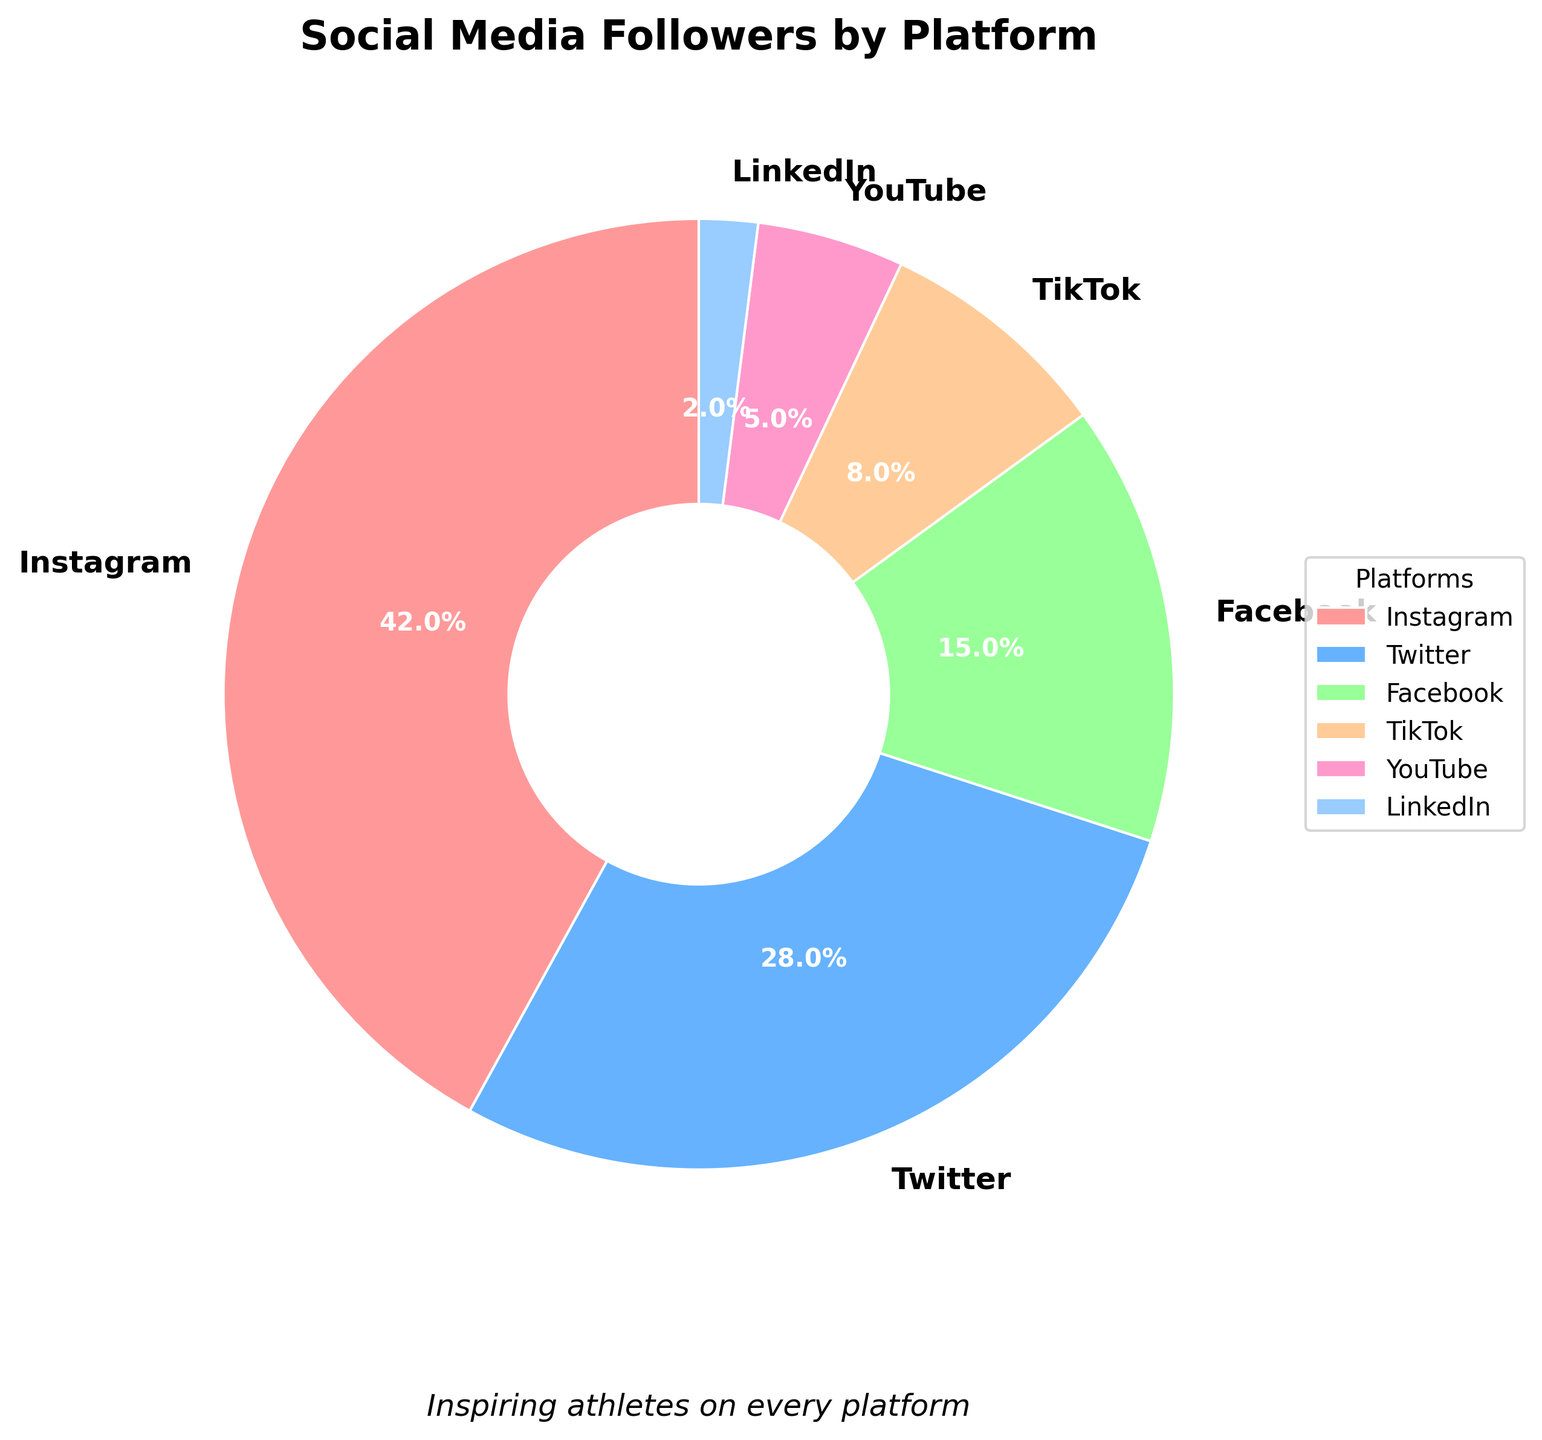Which platform has the highest percentage of followers? The pie chart visually displays that Instagram occupies the largest segment, evidenced by its bigger wedge.
Answer: Instagram What is the combined percentage of followers on Twitter and Facebook? To find the combined percentage, add the percentages of Twitter (28%) and Facebook (15%): 28 + 15 = 43.
Answer: 43% Which platform has fewer followers, TikTok or YouTube? By looking at the pie chart, the wedge for TikTok is larger than that for YouTube, indicating that TikTok has more followers. Therefore, YouTube has fewer followers.
Answer: YouTube By how much does the percentage of Instagram followers exceed that of LinkedIn followers? To find the difference, subtract the percentage of LinkedIn (2%) from Instagram (42%): 42 - 2 = 40.
Answer: 40% What could be inferred about the general popularity of LinkedIn compared to other platforms? The pie chart shows that LinkedIn has the smallest wedge, implying it has the least percentage of followers compared to other platforms.
Answer: Least popular How many platforms have a percentage of followers lower than 10%? From the pie chart, the platforms with percentages lower than 10% are TikTok (8%), YouTube (5%), and LinkedIn (2%). This counts for 3 platforms.
Answer: 3 Rank the platforms from the highest to the lowest percentage of followers. By observing the sizes of the wedges, the ranking is: Instagram (42%), Twitter (28%), Facebook (15%), TikTok (8%), YouTube (5%), LinkedIn (2%).
Answer: Instagram, Twitter, Facebook, TikTok, YouTube, LinkedIn What does the subtitle "Inspiring athletes on every platform" suggest about the purpose of the data? The subtitle implies that the data denotes the presence of athletes on different social media platforms, potentially highlighting their reach and influence.
Answer: Athlete influence on social media 